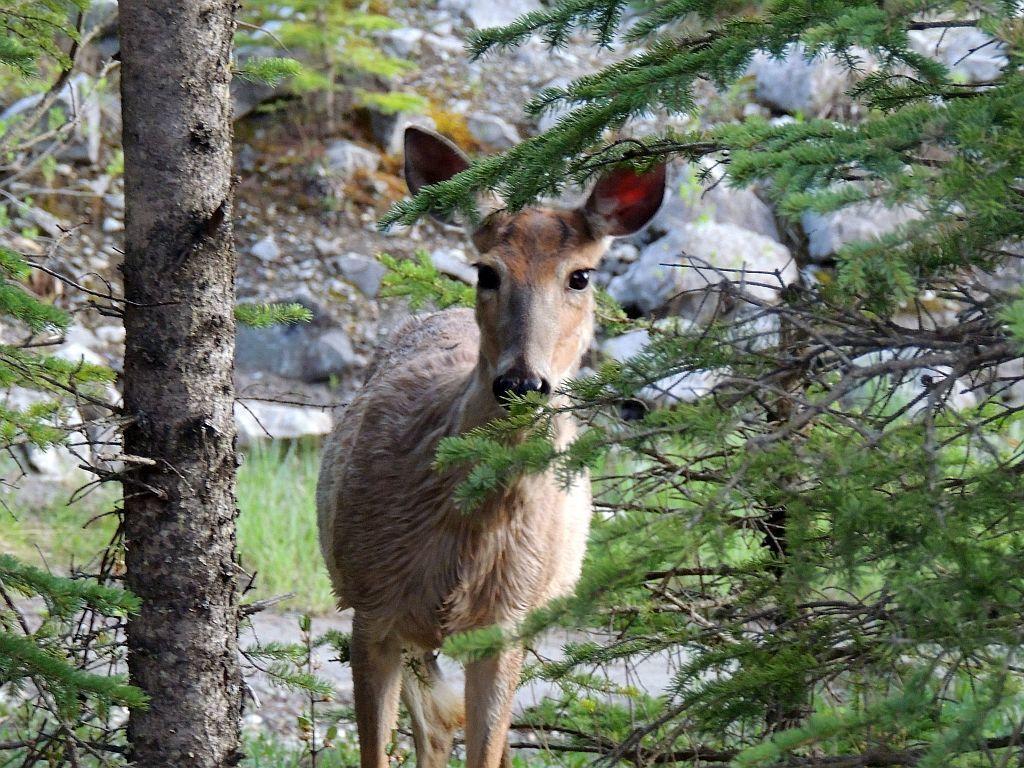Describe this image in one or two sentences. In the center of the image we can see an animal. We can also see the bark of a tree, some plants, stones and some branches of the trees. 